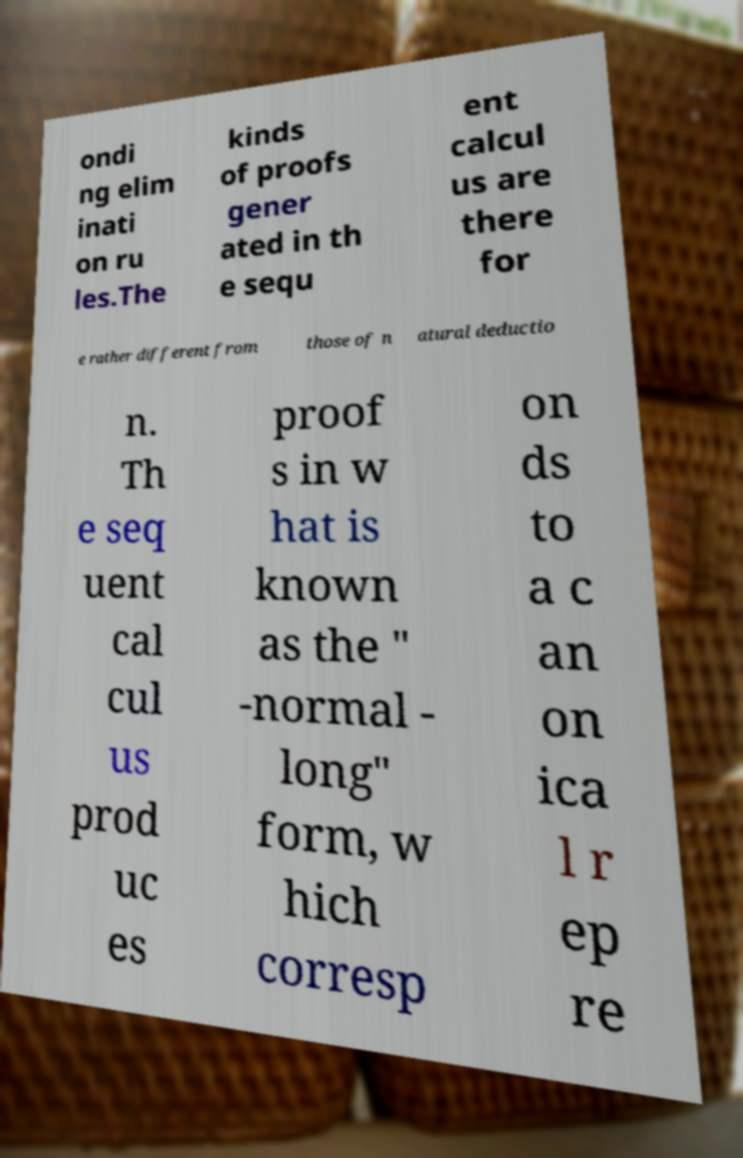For documentation purposes, I need the text within this image transcribed. Could you provide that? ondi ng elim inati on ru les.The kinds of proofs gener ated in th e sequ ent calcul us are there for e rather different from those of n atural deductio n. Th e seq uent cal cul us prod uc es proof s in w hat is known as the " -normal - long" form, w hich corresp on ds to a c an on ica l r ep re 